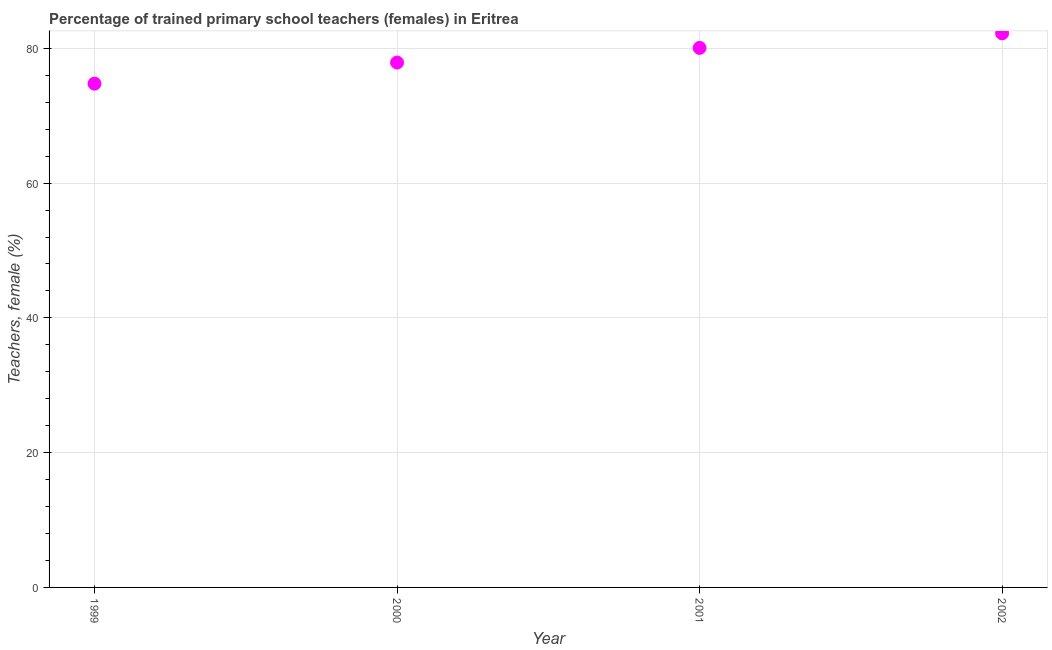What is the percentage of trained female teachers in 2000?
Ensure brevity in your answer.  77.89. Across all years, what is the maximum percentage of trained female teachers?
Your answer should be very brief. 82.23. Across all years, what is the minimum percentage of trained female teachers?
Offer a terse response. 74.76. What is the sum of the percentage of trained female teachers?
Your response must be concise. 314.94. What is the difference between the percentage of trained female teachers in 2000 and 2002?
Provide a short and direct response. -4.34. What is the average percentage of trained female teachers per year?
Offer a terse response. 78.74. What is the median percentage of trained female teachers?
Make the answer very short. 78.98. Do a majority of the years between 2002 and 1999 (inclusive) have percentage of trained female teachers greater than 72 %?
Provide a short and direct response. Yes. What is the ratio of the percentage of trained female teachers in 1999 to that in 2000?
Your response must be concise. 0.96. Is the percentage of trained female teachers in 1999 less than that in 2002?
Offer a terse response. Yes. What is the difference between the highest and the second highest percentage of trained female teachers?
Keep it short and to the point. 2.16. What is the difference between the highest and the lowest percentage of trained female teachers?
Your answer should be compact. 7.47. What is the difference between two consecutive major ticks on the Y-axis?
Offer a terse response. 20. Does the graph contain any zero values?
Offer a very short reply. No. Does the graph contain grids?
Provide a succinct answer. Yes. What is the title of the graph?
Offer a very short reply. Percentage of trained primary school teachers (females) in Eritrea. What is the label or title of the Y-axis?
Ensure brevity in your answer.  Teachers, female (%). What is the Teachers, female (%) in 1999?
Give a very brief answer. 74.76. What is the Teachers, female (%) in 2000?
Your answer should be very brief. 77.89. What is the Teachers, female (%) in 2001?
Provide a short and direct response. 80.07. What is the Teachers, female (%) in 2002?
Provide a succinct answer. 82.23. What is the difference between the Teachers, female (%) in 1999 and 2000?
Provide a succinct answer. -3.13. What is the difference between the Teachers, female (%) in 1999 and 2001?
Provide a succinct answer. -5.31. What is the difference between the Teachers, female (%) in 1999 and 2002?
Offer a terse response. -7.47. What is the difference between the Teachers, female (%) in 2000 and 2001?
Your response must be concise. -2.17. What is the difference between the Teachers, female (%) in 2000 and 2002?
Offer a very short reply. -4.34. What is the difference between the Teachers, female (%) in 2001 and 2002?
Provide a short and direct response. -2.16. What is the ratio of the Teachers, female (%) in 1999 to that in 2000?
Offer a very short reply. 0.96. What is the ratio of the Teachers, female (%) in 1999 to that in 2001?
Provide a succinct answer. 0.93. What is the ratio of the Teachers, female (%) in 1999 to that in 2002?
Ensure brevity in your answer.  0.91. What is the ratio of the Teachers, female (%) in 2000 to that in 2001?
Offer a very short reply. 0.97. What is the ratio of the Teachers, female (%) in 2000 to that in 2002?
Your response must be concise. 0.95. What is the ratio of the Teachers, female (%) in 2001 to that in 2002?
Your answer should be compact. 0.97. 